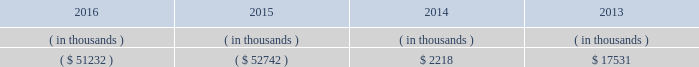Entergy arkansas , inc .
And subsidiaries management 2019s financial discussion and analysis stock restrict the amount of retained earnings available for the payment of cash dividends or other distributions on its common and preferred stock .
Sources of capital entergy arkansas 2019s sources to meet its capital requirements include : 2022 internally generated funds ; 2022 cash on hand ; 2022 debt or preferred stock issuances ; and 2022 bank financing under new or existing facilities .
Entergy arkansas may refinance , redeem , or otherwise retire debt and preferred stock prior to maturity , to the extent market conditions and interest and dividend rates are favorable .
All debt and common and preferred stock issuances by entergy arkansas require prior regulatory approval .
Preferred stock and debt issuances are also subject to issuance tests set forth in entergy arkansas 2019s corporate charters , bond indentures , and other agreements .
Entergy arkansas has sufficient capacity under these tests to meet its foreseeable capital needs .
Entergy arkansas 2019s receivables from or ( payables to ) the money pool were as follows as of december 31 for each of the following years. .
See note 4 to the financial statements for a description of the money pool .
Entergy arkansas has a credit facility in the amount of $ 150 million scheduled to expire in august 2021 .
Entergy arkansas also has a $ 20 million credit facility scheduled to expire in april 2017 .
The $ 150 million credit facility allows entergy arkansas to issue letters of credit against 50% ( 50 % ) of the borrowing capacity of the facility .
As of december 31 , 2016 , there were no cash borrowings and no letters of credit outstanding under the credit facilities .
In addition , entergy arkansas is a party to an uncommitted letter of credit facility as a means to post collateral to support its obligations under miso .
As of december 31 , 2016 , a $ 1 million letter of credit was outstanding under entergy arkansas 2019s uncommitted letter of credit facility .
See note 4 to the financial statements for additional discussion of the credit facilities .
The entergy arkansas nuclear fuel company variable interest entity has a credit facility in the amount of $ 80 million scheduled to expire in may 2019 .
As of december 31 , 2016 , no letters of credit were outstanding under the credit facility to support commercial paper issued by the entergy arkansas nuclear fuel company variable interest entity .
See note 4 to the financial statements for additional discussion of the nuclear fuel company variable interest entity credit facility .
Entergy arkansas obtained authorizations from the ferc through october 2017 for short-term borrowings not to exceed an aggregate amount of $ 250 million at any time outstanding and long-term borrowings by its nuclear fuel company variable interest entity .
See note 4 to the financial statements for further discussion of entergy arkansas 2019s short-term borrowing limits .
The long-term securities issuances of entergy arkansas are limited to amounts authorized by the apsc and the tennessee regulatory authority ; the current authorizations extend through december 2018. .
How is cash flow of entergy arkansas affected by the change in balance of money pool from 2014 to 2015? 
Computations: (52742 + 2218)
Answer: 54960.0. 